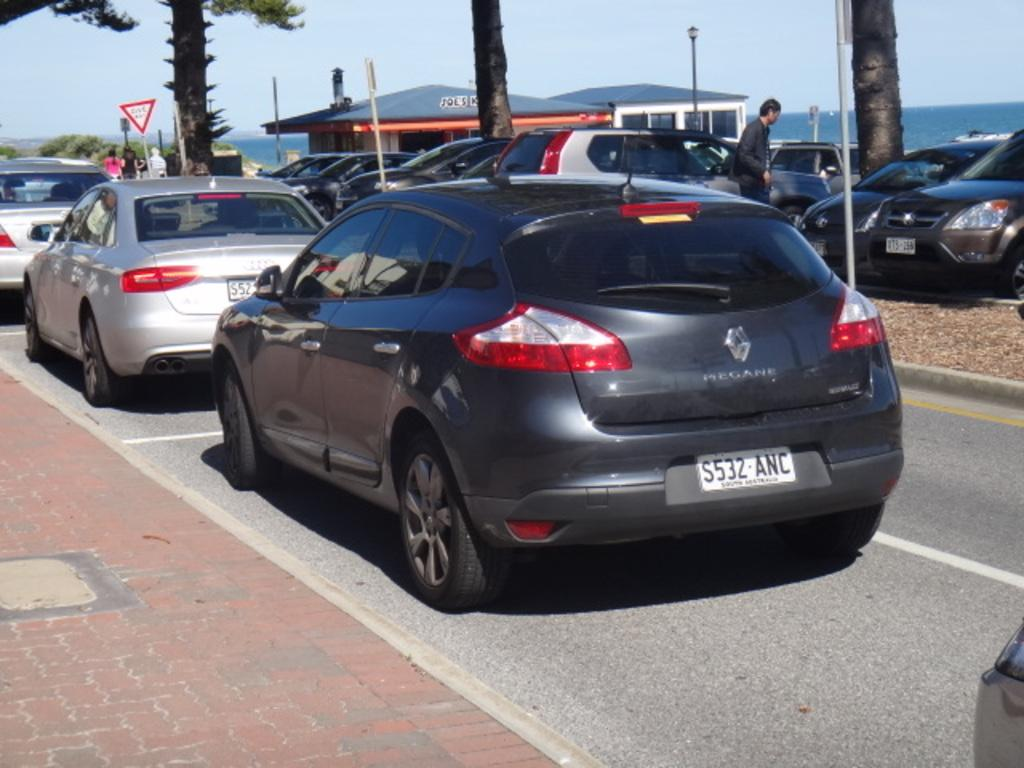What type of vehicles can be seen in the image? There are cars in the image. Can you describe the people in the image? There are people in the image. What can be seen in the background of the image? There are trees, sheds, poles, and the sky visible in the background of the image. What object is present in the image that might be used for displaying information? There is a board in the image. What type of statement can be seen written on the board in the image? There is no statement visible on the board in the image. What color is the chalk used to write the statement on the board in the image? There is no chalk or statement present on the board in the image. 